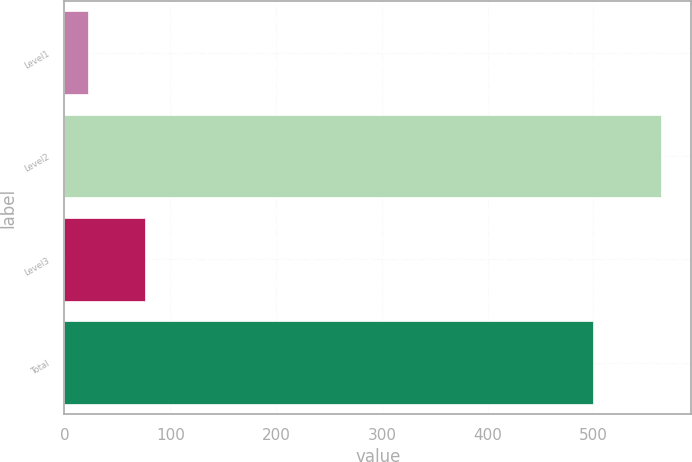Convert chart. <chart><loc_0><loc_0><loc_500><loc_500><bar_chart><fcel>Level1<fcel>Level2<fcel>Level3<fcel>Total<nl><fcel>22<fcel>564<fcel>76.2<fcel>500<nl></chart> 